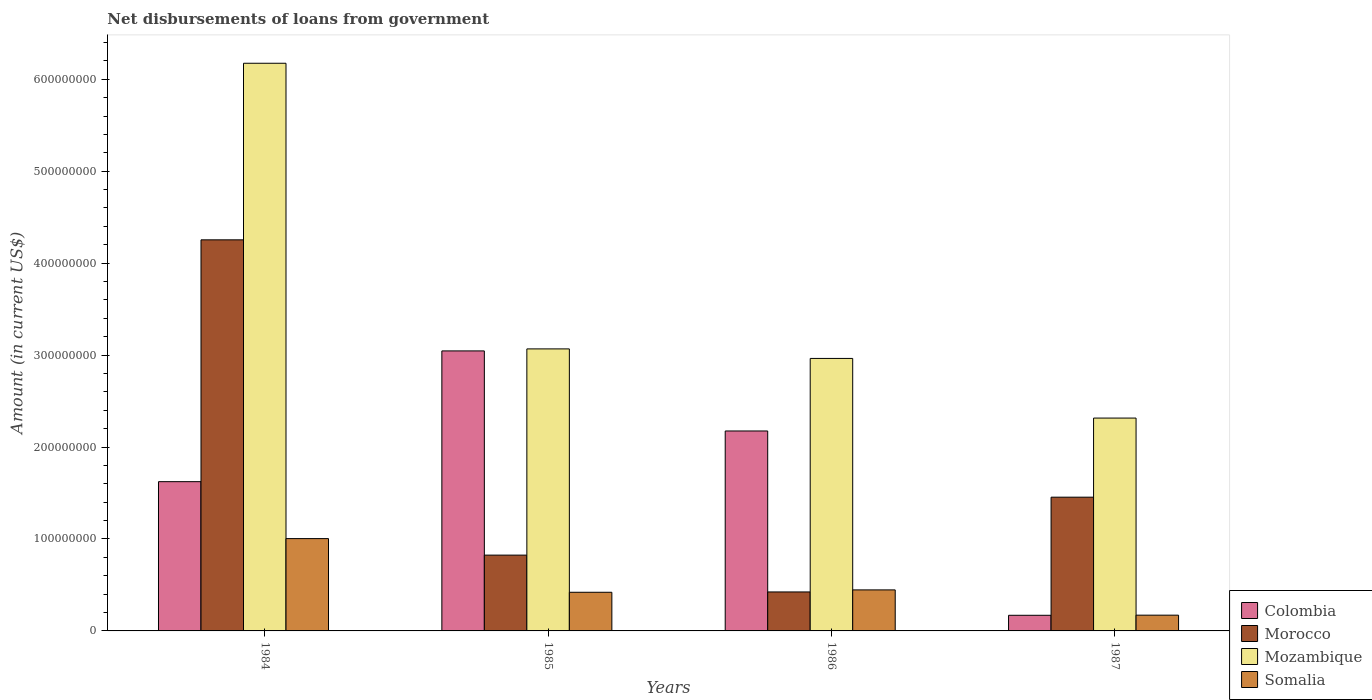How many groups of bars are there?
Ensure brevity in your answer.  4. Are the number of bars on each tick of the X-axis equal?
Your response must be concise. Yes. How many bars are there on the 2nd tick from the right?
Make the answer very short. 4. In how many cases, is the number of bars for a given year not equal to the number of legend labels?
Your answer should be very brief. 0. What is the amount of loan disbursed from government in Mozambique in 1986?
Provide a short and direct response. 2.96e+08. Across all years, what is the maximum amount of loan disbursed from government in Morocco?
Offer a very short reply. 4.25e+08. Across all years, what is the minimum amount of loan disbursed from government in Colombia?
Ensure brevity in your answer.  1.70e+07. In which year was the amount of loan disbursed from government in Somalia maximum?
Offer a very short reply. 1984. What is the total amount of loan disbursed from government in Morocco in the graph?
Your answer should be compact. 6.96e+08. What is the difference between the amount of loan disbursed from government in Morocco in 1984 and that in 1986?
Offer a very short reply. 3.83e+08. What is the difference between the amount of loan disbursed from government in Colombia in 1986 and the amount of loan disbursed from government in Mozambique in 1987?
Make the answer very short. -1.40e+07. What is the average amount of loan disbursed from government in Somalia per year?
Offer a very short reply. 5.11e+07. In the year 1985, what is the difference between the amount of loan disbursed from government in Somalia and amount of loan disbursed from government in Morocco?
Give a very brief answer. -4.04e+07. In how many years, is the amount of loan disbursed from government in Colombia greater than 540000000 US$?
Make the answer very short. 0. What is the ratio of the amount of loan disbursed from government in Morocco in 1985 to that in 1986?
Offer a terse response. 1.95. What is the difference between the highest and the second highest amount of loan disbursed from government in Colombia?
Ensure brevity in your answer.  8.71e+07. What is the difference between the highest and the lowest amount of loan disbursed from government in Morocco?
Offer a very short reply. 3.83e+08. In how many years, is the amount of loan disbursed from government in Somalia greater than the average amount of loan disbursed from government in Somalia taken over all years?
Your response must be concise. 1. What does the 1st bar from the right in 1985 represents?
Make the answer very short. Somalia. How many bars are there?
Your response must be concise. 16. Are all the bars in the graph horizontal?
Your answer should be very brief. No. How many years are there in the graph?
Keep it short and to the point. 4. What is the difference between two consecutive major ticks on the Y-axis?
Your answer should be compact. 1.00e+08. Does the graph contain grids?
Offer a terse response. No. Where does the legend appear in the graph?
Your answer should be compact. Bottom right. How many legend labels are there?
Your answer should be very brief. 4. What is the title of the graph?
Ensure brevity in your answer.  Net disbursements of loans from government. Does "Norway" appear as one of the legend labels in the graph?
Your response must be concise. No. What is the label or title of the X-axis?
Keep it short and to the point. Years. What is the Amount (in current US$) of Colombia in 1984?
Your answer should be very brief. 1.62e+08. What is the Amount (in current US$) of Morocco in 1984?
Offer a terse response. 4.25e+08. What is the Amount (in current US$) in Mozambique in 1984?
Give a very brief answer. 6.17e+08. What is the Amount (in current US$) of Somalia in 1984?
Ensure brevity in your answer.  1.00e+08. What is the Amount (in current US$) in Colombia in 1985?
Ensure brevity in your answer.  3.05e+08. What is the Amount (in current US$) of Morocco in 1985?
Your answer should be compact. 8.24e+07. What is the Amount (in current US$) of Mozambique in 1985?
Give a very brief answer. 3.07e+08. What is the Amount (in current US$) in Somalia in 1985?
Offer a terse response. 4.20e+07. What is the Amount (in current US$) of Colombia in 1986?
Offer a terse response. 2.17e+08. What is the Amount (in current US$) of Morocco in 1986?
Provide a short and direct response. 4.24e+07. What is the Amount (in current US$) in Mozambique in 1986?
Offer a very short reply. 2.96e+08. What is the Amount (in current US$) in Somalia in 1986?
Keep it short and to the point. 4.46e+07. What is the Amount (in current US$) of Colombia in 1987?
Provide a short and direct response. 1.70e+07. What is the Amount (in current US$) in Morocco in 1987?
Make the answer very short. 1.45e+08. What is the Amount (in current US$) in Mozambique in 1987?
Offer a very short reply. 2.31e+08. What is the Amount (in current US$) in Somalia in 1987?
Your answer should be very brief. 1.71e+07. Across all years, what is the maximum Amount (in current US$) of Colombia?
Offer a very short reply. 3.05e+08. Across all years, what is the maximum Amount (in current US$) in Morocco?
Keep it short and to the point. 4.25e+08. Across all years, what is the maximum Amount (in current US$) of Mozambique?
Your response must be concise. 6.17e+08. Across all years, what is the maximum Amount (in current US$) in Somalia?
Provide a succinct answer. 1.00e+08. Across all years, what is the minimum Amount (in current US$) of Colombia?
Offer a very short reply. 1.70e+07. Across all years, what is the minimum Amount (in current US$) in Morocco?
Ensure brevity in your answer.  4.24e+07. Across all years, what is the minimum Amount (in current US$) in Mozambique?
Provide a short and direct response. 2.31e+08. Across all years, what is the minimum Amount (in current US$) in Somalia?
Ensure brevity in your answer.  1.71e+07. What is the total Amount (in current US$) in Colombia in the graph?
Make the answer very short. 7.01e+08. What is the total Amount (in current US$) of Morocco in the graph?
Offer a very short reply. 6.96e+08. What is the total Amount (in current US$) of Mozambique in the graph?
Make the answer very short. 1.45e+09. What is the total Amount (in current US$) of Somalia in the graph?
Your response must be concise. 2.04e+08. What is the difference between the Amount (in current US$) of Colombia in 1984 and that in 1985?
Your answer should be compact. -1.42e+08. What is the difference between the Amount (in current US$) in Morocco in 1984 and that in 1985?
Keep it short and to the point. 3.43e+08. What is the difference between the Amount (in current US$) in Mozambique in 1984 and that in 1985?
Provide a short and direct response. 3.11e+08. What is the difference between the Amount (in current US$) in Somalia in 1984 and that in 1985?
Provide a succinct answer. 5.84e+07. What is the difference between the Amount (in current US$) of Colombia in 1984 and that in 1986?
Ensure brevity in your answer.  -5.51e+07. What is the difference between the Amount (in current US$) in Morocco in 1984 and that in 1986?
Offer a very short reply. 3.83e+08. What is the difference between the Amount (in current US$) in Mozambique in 1984 and that in 1986?
Offer a terse response. 3.21e+08. What is the difference between the Amount (in current US$) of Somalia in 1984 and that in 1986?
Provide a succinct answer. 5.58e+07. What is the difference between the Amount (in current US$) of Colombia in 1984 and that in 1987?
Give a very brief answer. 1.45e+08. What is the difference between the Amount (in current US$) of Morocco in 1984 and that in 1987?
Your answer should be compact. 2.80e+08. What is the difference between the Amount (in current US$) of Mozambique in 1984 and that in 1987?
Your answer should be compact. 3.86e+08. What is the difference between the Amount (in current US$) of Somalia in 1984 and that in 1987?
Make the answer very short. 8.33e+07. What is the difference between the Amount (in current US$) in Colombia in 1985 and that in 1986?
Offer a terse response. 8.71e+07. What is the difference between the Amount (in current US$) in Morocco in 1985 and that in 1986?
Your answer should be very brief. 4.01e+07. What is the difference between the Amount (in current US$) in Mozambique in 1985 and that in 1986?
Ensure brevity in your answer.  1.04e+07. What is the difference between the Amount (in current US$) of Somalia in 1985 and that in 1986?
Keep it short and to the point. -2.58e+06. What is the difference between the Amount (in current US$) in Colombia in 1985 and that in 1987?
Keep it short and to the point. 2.88e+08. What is the difference between the Amount (in current US$) of Morocco in 1985 and that in 1987?
Your response must be concise. -6.30e+07. What is the difference between the Amount (in current US$) in Mozambique in 1985 and that in 1987?
Make the answer very short. 7.52e+07. What is the difference between the Amount (in current US$) of Somalia in 1985 and that in 1987?
Offer a very short reply. 2.49e+07. What is the difference between the Amount (in current US$) of Colombia in 1986 and that in 1987?
Your response must be concise. 2.00e+08. What is the difference between the Amount (in current US$) of Morocco in 1986 and that in 1987?
Give a very brief answer. -1.03e+08. What is the difference between the Amount (in current US$) in Mozambique in 1986 and that in 1987?
Your answer should be compact. 6.49e+07. What is the difference between the Amount (in current US$) of Somalia in 1986 and that in 1987?
Give a very brief answer. 2.75e+07. What is the difference between the Amount (in current US$) of Colombia in 1984 and the Amount (in current US$) of Morocco in 1985?
Your answer should be very brief. 7.99e+07. What is the difference between the Amount (in current US$) in Colombia in 1984 and the Amount (in current US$) in Mozambique in 1985?
Your answer should be compact. -1.44e+08. What is the difference between the Amount (in current US$) of Colombia in 1984 and the Amount (in current US$) of Somalia in 1985?
Keep it short and to the point. 1.20e+08. What is the difference between the Amount (in current US$) of Morocco in 1984 and the Amount (in current US$) of Mozambique in 1985?
Provide a succinct answer. 1.19e+08. What is the difference between the Amount (in current US$) of Morocco in 1984 and the Amount (in current US$) of Somalia in 1985?
Your response must be concise. 3.83e+08. What is the difference between the Amount (in current US$) of Mozambique in 1984 and the Amount (in current US$) of Somalia in 1985?
Your answer should be very brief. 5.75e+08. What is the difference between the Amount (in current US$) in Colombia in 1984 and the Amount (in current US$) in Morocco in 1986?
Offer a very short reply. 1.20e+08. What is the difference between the Amount (in current US$) in Colombia in 1984 and the Amount (in current US$) in Mozambique in 1986?
Offer a very short reply. -1.34e+08. What is the difference between the Amount (in current US$) of Colombia in 1984 and the Amount (in current US$) of Somalia in 1986?
Your response must be concise. 1.18e+08. What is the difference between the Amount (in current US$) in Morocco in 1984 and the Amount (in current US$) in Mozambique in 1986?
Give a very brief answer. 1.29e+08. What is the difference between the Amount (in current US$) in Morocco in 1984 and the Amount (in current US$) in Somalia in 1986?
Your answer should be very brief. 3.81e+08. What is the difference between the Amount (in current US$) of Mozambique in 1984 and the Amount (in current US$) of Somalia in 1986?
Give a very brief answer. 5.73e+08. What is the difference between the Amount (in current US$) of Colombia in 1984 and the Amount (in current US$) of Morocco in 1987?
Keep it short and to the point. 1.69e+07. What is the difference between the Amount (in current US$) in Colombia in 1984 and the Amount (in current US$) in Mozambique in 1987?
Make the answer very short. -6.92e+07. What is the difference between the Amount (in current US$) in Colombia in 1984 and the Amount (in current US$) in Somalia in 1987?
Make the answer very short. 1.45e+08. What is the difference between the Amount (in current US$) in Morocco in 1984 and the Amount (in current US$) in Mozambique in 1987?
Your response must be concise. 1.94e+08. What is the difference between the Amount (in current US$) of Morocco in 1984 and the Amount (in current US$) of Somalia in 1987?
Give a very brief answer. 4.08e+08. What is the difference between the Amount (in current US$) of Mozambique in 1984 and the Amount (in current US$) of Somalia in 1987?
Offer a terse response. 6.00e+08. What is the difference between the Amount (in current US$) in Colombia in 1985 and the Amount (in current US$) in Morocco in 1986?
Keep it short and to the point. 2.62e+08. What is the difference between the Amount (in current US$) of Colombia in 1985 and the Amount (in current US$) of Mozambique in 1986?
Your response must be concise. 8.18e+06. What is the difference between the Amount (in current US$) in Colombia in 1985 and the Amount (in current US$) in Somalia in 1986?
Offer a terse response. 2.60e+08. What is the difference between the Amount (in current US$) in Morocco in 1985 and the Amount (in current US$) in Mozambique in 1986?
Give a very brief answer. -2.14e+08. What is the difference between the Amount (in current US$) of Morocco in 1985 and the Amount (in current US$) of Somalia in 1986?
Offer a terse response. 3.78e+07. What is the difference between the Amount (in current US$) of Mozambique in 1985 and the Amount (in current US$) of Somalia in 1986?
Offer a terse response. 2.62e+08. What is the difference between the Amount (in current US$) of Colombia in 1985 and the Amount (in current US$) of Morocco in 1987?
Your answer should be compact. 1.59e+08. What is the difference between the Amount (in current US$) in Colombia in 1985 and the Amount (in current US$) in Mozambique in 1987?
Make the answer very short. 7.31e+07. What is the difference between the Amount (in current US$) of Colombia in 1985 and the Amount (in current US$) of Somalia in 1987?
Give a very brief answer. 2.87e+08. What is the difference between the Amount (in current US$) of Morocco in 1985 and the Amount (in current US$) of Mozambique in 1987?
Ensure brevity in your answer.  -1.49e+08. What is the difference between the Amount (in current US$) in Morocco in 1985 and the Amount (in current US$) in Somalia in 1987?
Provide a short and direct response. 6.53e+07. What is the difference between the Amount (in current US$) of Mozambique in 1985 and the Amount (in current US$) of Somalia in 1987?
Provide a short and direct response. 2.90e+08. What is the difference between the Amount (in current US$) of Colombia in 1986 and the Amount (in current US$) of Morocco in 1987?
Offer a terse response. 7.20e+07. What is the difference between the Amount (in current US$) in Colombia in 1986 and the Amount (in current US$) in Mozambique in 1987?
Keep it short and to the point. -1.40e+07. What is the difference between the Amount (in current US$) of Colombia in 1986 and the Amount (in current US$) of Somalia in 1987?
Provide a short and direct response. 2.00e+08. What is the difference between the Amount (in current US$) of Morocco in 1986 and the Amount (in current US$) of Mozambique in 1987?
Your response must be concise. -1.89e+08. What is the difference between the Amount (in current US$) in Morocco in 1986 and the Amount (in current US$) in Somalia in 1987?
Provide a succinct answer. 2.52e+07. What is the difference between the Amount (in current US$) in Mozambique in 1986 and the Amount (in current US$) in Somalia in 1987?
Your answer should be very brief. 2.79e+08. What is the average Amount (in current US$) of Colombia per year?
Your answer should be very brief. 1.75e+08. What is the average Amount (in current US$) in Morocco per year?
Provide a short and direct response. 1.74e+08. What is the average Amount (in current US$) of Mozambique per year?
Your answer should be very brief. 3.63e+08. What is the average Amount (in current US$) in Somalia per year?
Offer a terse response. 5.11e+07. In the year 1984, what is the difference between the Amount (in current US$) in Colombia and Amount (in current US$) in Morocco?
Provide a succinct answer. -2.63e+08. In the year 1984, what is the difference between the Amount (in current US$) of Colombia and Amount (in current US$) of Mozambique?
Your answer should be very brief. -4.55e+08. In the year 1984, what is the difference between the Amount (in current US$) in Colombia and Amount (in current US$) in Somalia?
Your answer should be very brief. 6.19e+07. In the year 1984, what is the difference between the Amount (in current US$) in Morocco and Amount (in current US$) in Mozambique?
Provide a short and direct response. -1.92e+08. In the year 1984, what is the difference between the Amount (in current US$) in Morocco and Amount (in current US$) in Somalia?
Your answer should be compact. 3.25e+08. In the year 1984, what is the difference between the Amount (in current US$) of Mozambique and Amount (in current US$) of Somalia?
Keep it short and to the point. 5.17e+08. In the year 1985, what is the difference between the Amount (in current US$) of Colombia and Amount (in current US$) of Morocco?
Make the answer very short. 2.22e+08. In the year 1985, what is the difference between the Amount (in current US$) of Colombia and Amount (in current US$) of Mozambique?
Keep it short and to the point. -2.19e+06. In the year 1985, what is the difference between the Amount (in current US$) in Colombia and Amount (in current US$) in Somalia?
Offer a terse response. 2.62e+08. In the year 1985, what is the difference between the Amount (in current US$) in Morocco and Amount (in current US$) in Mozambique?
Your response must be concise. -2.24e+08. In the year 1985, what is the difference between the Amount (in current US$) in Morocco and Amount (in current US$) in Somalia?
Ensure brevity in your answer.  4.04e+07. In the year 1985, what is the difference between the Amount (in current US$) in Mozambique and Amount (in current US$) in Somalia?
Your answer should be very brief. 2.65e+08. In the year 1986, what is the difference between the Amount (in current US$) in Colombia and Amount (in current US$) in Morocco?
Your response must be concise. 1.75e+08. In the year 1986, what is the difference between the Amount (in current US$) of Colombia and Amount (in current US$) of Mozambique?
Your response must be concise. -7.89e+07. In the year 1986, what is the difference between the Amount (in current US$) in Colombia and Amount (in current US$) in Somalia?
Your answer should be compact. 1.73e+08. In the year 1986, what is the difference between the Amount (in current US$) of Morocco and Amount (in current US$) of Mozambique?
Offer a very short reply. -2.54e+08. In the year 1986, what is the difference between the Amount (in current US$) of Morocco and Amount (in current US$) of Somalia?
Give a very brief answer. -2.24e+06. In the year 1986, what is the difference between the Amount (in current US$) in Mozambique and Amount (in current US$) in Somalia?
Keep it short and to the point. 2.52e+08. In the year 1987, what is the difference between the Amount (in current US$) in Colombia and Amount (in current US$) in Morocco?
Make the answer very short. -1.28e+08. In the year 1987, what is the difference between the Amount (in current US$) in Colombia and Amount (in current US$) in Mozambique?
Give a very brief answer. -2.14e+08. In the year 1987, what is the difference between the Amount (in current US$) of Colombia and Amount (in current US$) of Somalia?
Offer a terse response. -1.31e+05. In the year 1987, what is the difference between the Amount (in current US$) of Morocco and Amount (in current US$) of Mozambique?
Keep it short and to the point. -8.60e+07. In the year 1987, what is the difference between the Amount (in current US$) of Morocco and Amount (in current US$) of Somalia?
Your answer should be very brief. 1.28e+08. In the year 1987, what is the difference between the Amount (in current US$) in Mozambique and Amount (in current US$) in Somalia?
Keep it short and to the point. 2.14e+08. What is the ratio of the Amount (in current US$) of Colombia in 1984 to that in 1985?
Ensure brevity in your answer.  0.53. What is the ratio of the Amount (in current US$) of Morocco in 1984 to that in 1985?
Give a very brief answer. 5.16. What is the ratio of the Amount (in current US$) in Mozambique in 1984 to that in 1985?
Your response must be concise. 2.01. What is the ratio of the Amount (in current US$) in Somalia in 1984 to that in 1985?
Offer a terse response. 2.39. What is the ratio of the Amount (in current US$) of Colombia in 1984 to that in 1986?
Give a very brief answer. 0.75. What is the ratio of the Amount (in current US$) of Morocco in 1984 to that in 1986?
Offer a very short reply. 10.04. What is the ratio of the Amount (in current US$) of Mozambique in 1984 to that in 1986?
Give a very brief answer. 2.08. What is the ratio of the Amount (in current US$) of Somalia in 1984 to that in 1986?
Keep it short and to the point. 2.25. What is the ratio of the Amount (in current US$) in Colombia in 1984 to that in 1987?
Offer a very short reply. 9.55. What is the ratio of the Amount (in current US$) in Morocco in 1984 to that in 1987?
Offer a very short reply. 2.92. What is the ratio of the Amount (in current US$) in Mozambique in 1984 to that in 1987?
Provide a succinct answer. 2.67. What is the ratio of the Amount (in current US$) in Somalia in 1984 to that in 1987?
Give a very brief answer. 5.86. What is the ratio of the Amount (in current US$) in Colombia in 1985 to that in 1986?
Give a very brief answer. 1.4. What is the ratio of the Amount (in current US$) in Morocco in 1985 to that in 1986?
Your answer should be very brief. 1.95. What is the ratio of the Amount (in current US$) in Mozambique in 1985 to that in 1986?
Offer a very short reply. 1.03. What is the ratio of the Amount (in current US$) in Somalia in 1985 to that in 1986?
Ensure brevity in your answer.  0.94. What is the ratio of the Amount (in current US$) of Colombia in 1985 to that in 1987?
Give a very brief answer. 17.91. What is the ratio of the Amount (in current US$) of Morocco in 1985 to that in 1987?
Provide a short and direct response. 0.57. What is the ratio of the Amount (in current US$) of Mozambique in 1985 to that in 1987?
Your answer should be compact. 1.32. What is the ratio of the Amount (in current US$) of Somalia in 1985 to that in 1987?
Offer a terse response. 2.45. What is the ratio of the Amount (in current US$) of Colombia in 1986 to that in 1987?
Offer a terse response. 12.79. What is the ratio of the Amount (in current US$) in Morocco in 1986 to that in 1987?
Your answer should be very brief. 0.29. What is the ratio of the Amount (in current US$) in Mozambique in 1986 to that in 1987?
Provide a short and direct response. 1.28. What is the ratio of the Amount (in current US$) in Somalia in 1986 to that in 1987?
Your response must be concise. 2.6. What is the difference between the highest and the second highest Amount (in current US$) in Colombia?
Your response must be concise. 8.71e+07. What is the difference between the highest and the second highest Amount (in current US$) in Morocco?
Ensure brevity in your answer.  2.80e+08. What is the difference between the highest and the second highest Amount (in current US$) of Mozambique?
Make the answer very short. 3.11e+08. What is the difference between the highest and the second highest Amount (in current US$) of Somalia?
Provide a short and direct response. 5.58e+07. What is the difference between the highest and the lowest Amount (in current US$) of Colombia?
Make the answer very short. 2.88e+08. What is the difference between the highest and the lowest Amount (in current US$) in Morocco?
Ensure brevity in your answer.  3.83e+08. What is the difference between the highest and the lowest Amount (in current US$) in Mozambique?
Ensure brevity in your answer.  3.86e+08. What is the difference between the highest and the lowest Amount (in current US$) in Somalia?
Offer a terse response. 8.33e+07. 